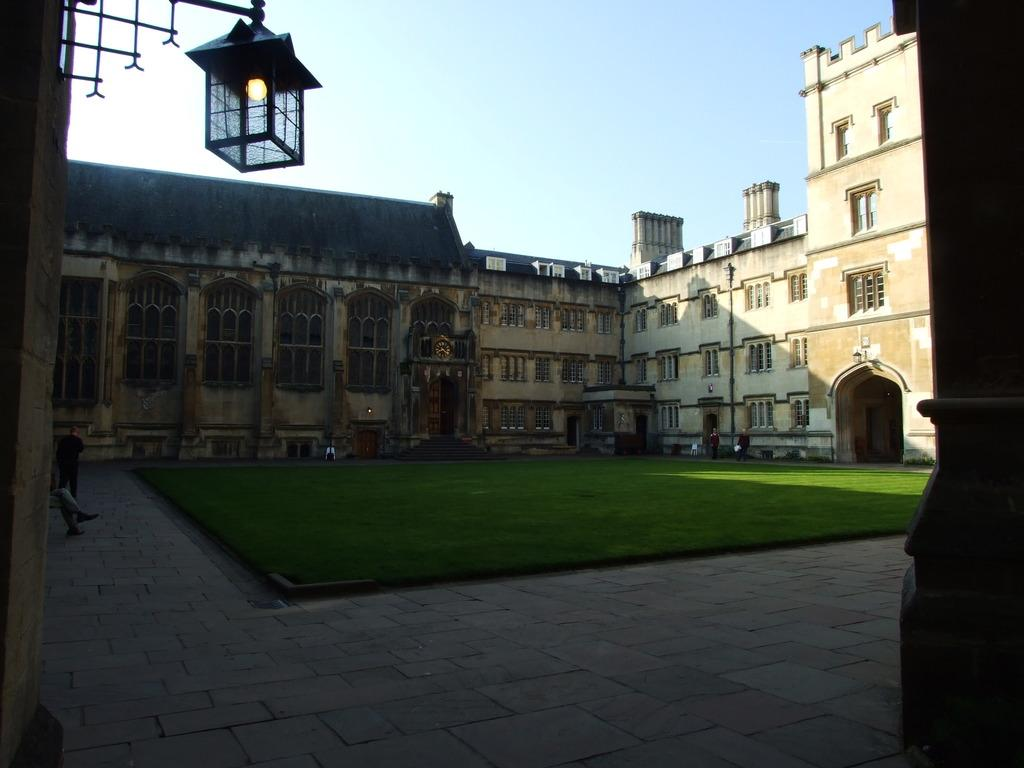What type of vegetation is present on the ground in the image? There is grass on the ground in the center of the image. What can be seen in the distance behind the grass? There are buildings in the background of the image. What type of lighting is present in the image? There is a light hanging in the front of the image. What type of bean is growing on the light in the image? There are no beans present in the image; the light is hanging without any beans growing on it. 